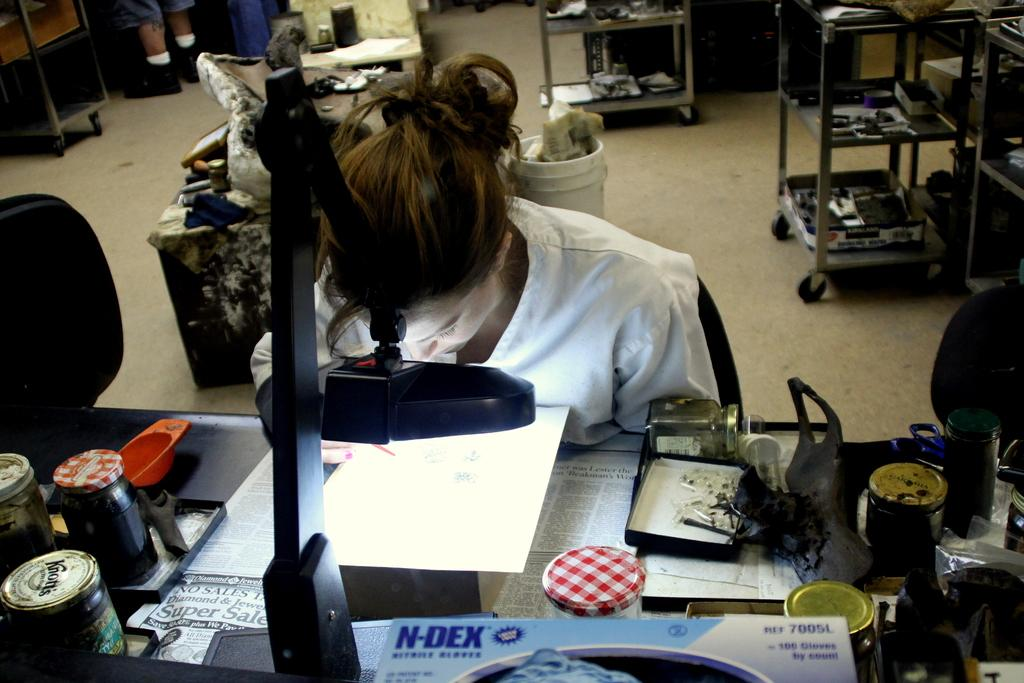Provide a one-sentence caption for the provided image. The lab uses the blue N-DEX brand gloves. 